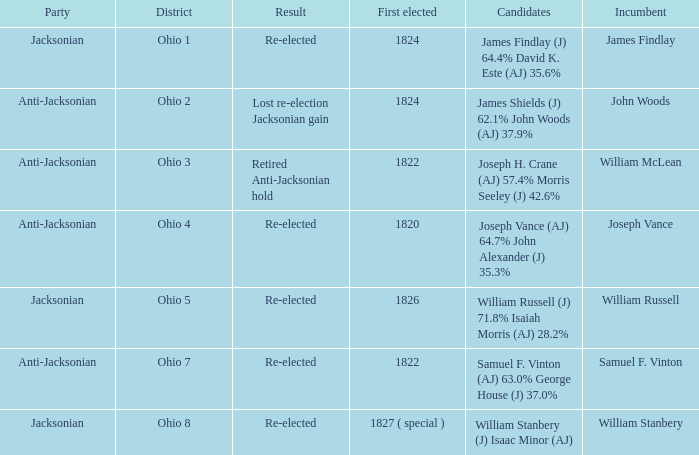What was the result for the candidate first elected in 1820? Re-elected. 